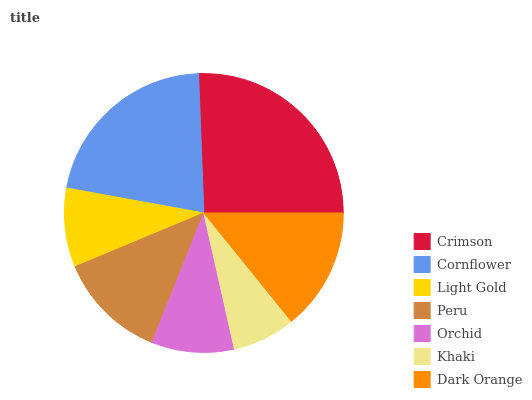Is Khaki the minimum?
Answer yes or no. Yes. Is Crimson the maximum?
Answer yes or no. Yes. Is Cornflower the minimum?
Answer yes or no. No. Is Cornflower the maximum?
Answer yes or no. No. Is Crimson greater than Cornflower?
Answer yes or no. Yes. Is Cornflower less than Crimson?
Answer yes or no. Yes. Is Cornflower greater than Crimson?
Answer yes or no. No. Is Crimson less than Cornflower?
Answer yes or no. No. Is Peru the high median?
Answer yes or no. Yes. Is Peru the low median?
Answer yes or no. Yes. Is Crimson the high median?
Answer yes or no. No. Is Crimson the low median?
Answer yes or no. No. 